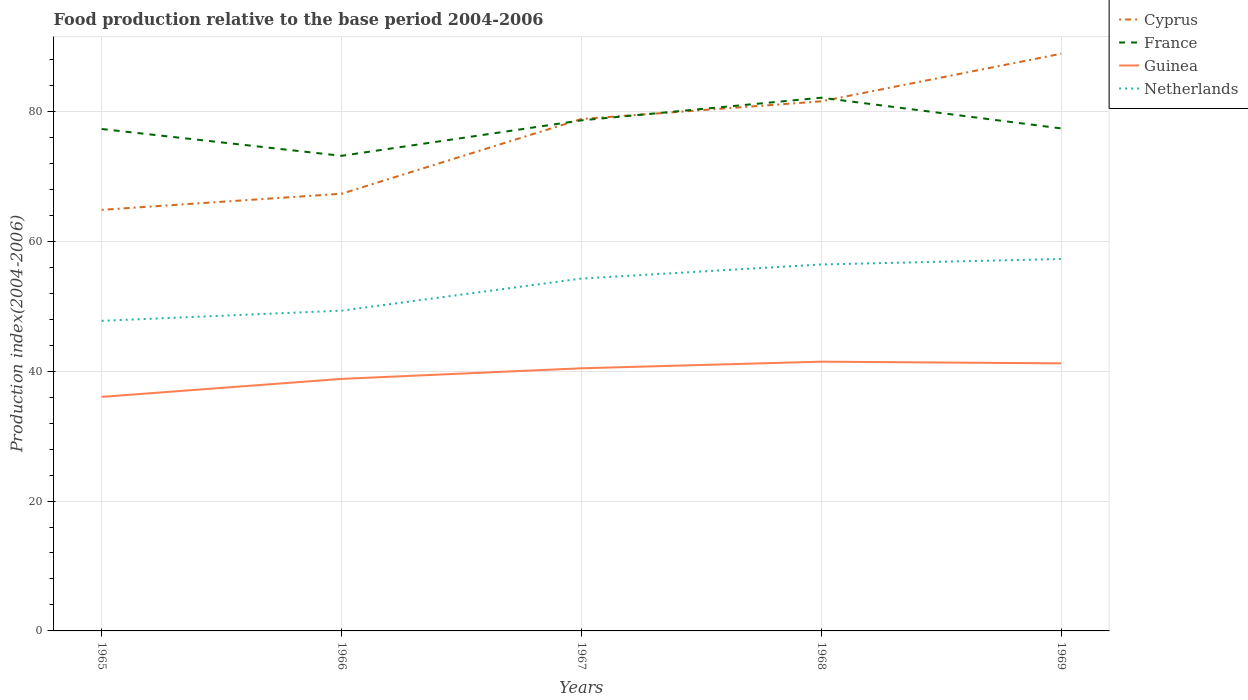How many different coloured lines are there?
Your response must be concise. 4. Across all years, what is the maximum food production index in France?
Your answer should be compact. 73.16. In which year was the food production index in Netherlands maximum?
Provide a succinct answer. 1965. What is the total food production index in France in the graph?
Offer a terse response. -3.49. What is the difference between the highest and the second highest food production index in Cyprus?
Offer a terse response. 24.04. Is the food production index in Cyprus strictly greater than the food production index in France over the years?
Your response must be concise. No. How many lines are there?
Provide a succinct answer. 4. Are the values on the major ticks of Y-axis written in scientific E-notation?
Your response must be concise. No. Does the graph contain any zero values?
Offer a very short reply. No. Does the graph contain grids?
Provide a short and direct response. Yes. What is the title of the graph?
Your answer should be compact. Food production relative to the base period 2004-2006. What is the label or title of the Y-axis?
Keep it short and to the point. Production index(2004-2006). What is the Production index(2004-2006) of Cyprus in 1965?
Ensure brevity in your answer.  64.84. What is the Production index(2004-2006) in France in 1965?
Keep it short and to the point. 77.29. What is the Production index(2004-2006) in Guinea in 1965?
Keep it short and to the point. 36.04. What is the Production index(2004-2006) of Netherlands in 1965?
Give a very brief answer. 47.75. What is the Production index(2004-2006) of Cyprus in 1966?
Give a very brief answer. 67.32. What is the Production index(2004-2006) in France in 1966?
Provide a succinct answer. 73.16. What is the Production index(2004-2006) of Guinea in 1966?
Make the answer very short. 38.81. What is the Production index(2004-2006) of Netherlands in 1966?
Make the answer very short. 49.32. What is the Production index(2004-2006) in Cyprus in 1967?
Offer a very short reply. 78.83. What is the Production index(2004-2006) in France in 1967?
Your answer should be compact. 78.62. What is the Production index(2004-2006) of Guinea in 1967?
Make the answer very short. 40.44. What is the Production index(2004-2006) of Netherlands in 1967?
Make the answer very short. 54.26. What is the Production index(2004-2006) of Cyprus in 1968?
Offer a very short reply. 81.55. What is the Production index(2004-2006) in France in 1968?
Provide a succinct answer. 82.11. What is the Production index(2004-2006) of Guinea in 1968?
Give a very brief answer. 41.46. What is the Production index(2004-2006) of Netherlands in 1968?
Give a very brief answer. 56.43. What is the Production index(2004-2006) in Cyprus in 1969?
Your answer should be compact. 88.88. What is the Production index(2004-2006) in France in 1969?
Your answer should be compact. 77.38. What is the Production index(2004-2006) of Guinea in 1969?
Provide a succinct answer. 41.2. What is the Production index(2004-2006) in Netherlands in 1969?
Make the answer very short. 57.27. Across all years, what is the maximum Production index(2004-2006) in Cyprus?
Your response must be concise. 88.88. Across all years, what is the maximum Production index(2004-2006) in France?
Offer a terse response. 82.11. Across all years, what is the maximum Production index(2004-2006) in Guinea?
Provide a short and direct response. 41.46. Across all years, what is the maximum Production index(2004-2006) in Netherlands?
Make the answer very short. 57.27. Across all years, what is the minimum Production index(2004-2006) in Cyprus?
Ensure brevity in your answer.  64.84. Across all years, what is the minimum Production index(2004-2006) in France?
Make the answer very short. 73.16. Across all years, what is the minimum Production index(2004-2006) in Guinea?
Provide a short and direct response. 36.04. Across all years, what is the minimum Production index(2004-2006) in Netherlands?
Your answer should be very brief. 47.75. What is the total Production index(2004-2006) of Cyprus in the graph?
Offer a terse response. 381.42. What is the total Production index(2004-2006) of France in the graph?
Offer a very short reply. 388.56. What is the total Production index(2004-2006) in Guinea in the graph?
Your response must be concise. 197.95. What is the total Production index(2004-2006) in Netherlands in the graph?
Make the answer very short. 265.03. What is the difference between the Production index(2004-2006) of Cyprus in 1965 and that in 1966?
Your answer should be compact. -2.48. What is the difference between the Production index(2004-2006) of France in 1965 and that in 1966?
Offer a terse response. 4.13. What is the difference between the Production index(2004-2006) of Guinea in 1965 and that in 1966?
Make the answer very short. -2.77. What is the difference between the Production index(2004-2006) of Netherlands in 1965 and that in 1966?
Your answer should be compact. -1.57. What is the difference between the Production index(2004-2006) in Cyprus in 1965 and that in 1967?
Offer a very short reply. -13.99. What is the difference between the Production index(2004-2006) of France in 1965 and that in 1967?
Provide a short and direct response. -1.33. What is the difference between the Production index(2004-2006) in Guinea in 1965 and that in 1967?
Ensure brevity in your answer.  -4.4. What is the difference between the Production index(2004-2006) in Netherlands in 1965 and that in 1967?
Provide a short and direct response. -6.51. What is the difference between the Production index(2004-2006) of Cyprus in 1965 and that in 1968?
Your answer should be very brief. -16.71. What is the difference between the Production index(2004-2006) of France in 1965 and that in 1968?
Make the answer very short. -4.82. What is the difference between the Production index(2004-2006) of Guinea in 1965 and that in 1968?
Make the answer very short. -5.42. What is the difference between the Production index(2004-2006) in Netherlands in 1965 and that in 1968?
Your answer should be very brief. -8.68. What is the difference between the Production index(2004-2006) of Cyprus in 1965 and that in 1969?
Offer a terse response. -24.04. What is the difference between the Production index(2004-2006) of France in 1965 and that in 1969?
Provide a succinct answer. -0.09. What is the difference between the Production index(2004-2006) in Guinea in 1965 and that in 1969?
Offer a terse response. -5.16. What is the difference between the Production index(2004-2006) of Netherlands in 1965 and that in 1969?
Offer a very short reply. -9.52. What is the difference between the Production index(2004-2006) of Cyprus in 1966 and that in 1967?
Make the answer very short. -11.51. What is the difference between the Production index(2004-2006) of France in 1966 and that in 1967?
Keep it short and to the point. -5.46. What is the difference between the Production index(2004-2006) of Guinea in 1966 and that in 1967?
Your answer should be very brief. -1.63. What is the difference between the Production index(2004-2006) of Netherlands in 1966 and that in 1967?
Make the answer very short. -4.94. What is the difference between the Production index(2004-2006) of Cyprus in 1966 and that in 1968?
Make the answer very short. -14.23. What is the difference between the Production index(2004-2006) in France in 1966 and that in 1968?
Offer a very short reply. -8.95. What is the difference between the Production index(2004-2006) of Guinea in 1966 and that in 1968?
Keep it short and to the point. -2.65. What is the difference between the Production index(2004-2006) of Netherlands in 1966 and that in 1968?
Your answer should be very brief. -7.11. What is the difference between the Production index(2004-2006) of Cyprus in 1966 and that in 1969?
Ensure brevity in your answer.  -21.56. What is the difference between the Production index(2004-2006) of France in 1966 and that in 1969?
Ensure brevity in your answer.  -4.22. What is the difference between the Production index(2004-2006) of Guinea in 1966 and that in 1969?
Give a very brief answer. -2.39. What is the difference between the Production index(2004-2006) of Netherlands in 1966 and that in 1969?
Provide a short and direct response. -7.95. What is the difference between the Production index(2004-2006) in Cyprus in 1967 and that in 1968?
Your response must be concise. -2.72. What is the difference between the Production index(2004-2006) in France in 1967 and that in 1968?
Offer a terse response. -3.49. What is the difference between the Production index(2004-2006) of Guinea in 1967 and that in 1968?
Offer a very short reply. -1.02. What is the difference between the Production index(2004-2006) in Netherlands in 1967 and that in 1968?
Offer a terse response. -2.17. What is the difference between the Production index(2004-2006) of Cyprus in 1967 and that in 1969?
Your response must be concise. -10.05. What is the difference between the Production index(2004-2006) of France in 1967 and that in 1969?
Your answer should be compact. 1.24. What is the difference between the Production index(2004-2006) in Guinea in 1967 and that in 1969?
Make the answer very short. -0.76. What is the difference between the Production index(2004-2006) of Netherlands in 1967 and that in 1969?
Offer a terse response. -3.01. What is the difference between the Production index(2004-2006) in Cyprus in 1968 and that in 1969?
Keep it short and to the point. -7.33. What is the difference between the Production index(2004-2006) of France in 1968 and that in 1969?
Give a very brief answer. 4.73. What is the difference between the Production index(2004-2006) of Guinea in 1968 and that in 1969?
Your response must be concise. 0.26. What is the difference between the Production index(2004-2006) in Netherlands in 1968 and that in 1969?
Provide a short and direct response. -0.84. What is the difference between the Production index(2004-2006) of Cyprus in 1965 and the Production index(2004-2006) of France in 1966?
Give a very brief answer. -8.32. What is the difference between the Production index(2004-2006) in Cyprus in 1965 and the Production index(2004-2006) in Guinea in 1966?
Your response must be concise. 26.03. What is the difference between the Production index(2004-2006) in Cyprus in 1965 and the Production index(2004-2006) in Netherlands in 1966?
Offer a very short reply. 15.52. What is the difference between the Production index(2004-2006) in France in 1965 and the Production index(2004-2006) in Guinea in 1966?
Offer a very short reply. 38.48. What is the difference between the Production index(2004-2006) of France in 1965 and the Production index(2004-2006) of Netherlands in 1966?
Your answer should be very brief. 27.97. What is the difference between the Production index(2004-2006) in Guinea in 1965 and the Production index(2004-2006) in Netherlands in 1966?
Ensure brevity in your answer.  -13.28. What is the difference between the Production index(2004-2006) of Cyprus in 1965 and the Production index(2004-2006) of France in 1967?
Offer a terse response. -13.78. What is the difference between the Production index(2004-2006) of Cyprus in 1965 and the Production index(2004-2006) of Guinea in 1967?
Provide a short and direct response. 24.4. What is the difference between the Production index(2004-2006) of Cyprus in 1965 and the Production index(2004-2006) of Netherlands in 1967?
Offer a very short reply. 10.58. What is the difference between the Production index(2004-2006) in France in 1965 and the Production index(2004-2006) in Guinea in 1967?
Give a very brief answer. 36.85. What is the difference between the Production index(2004-2006) of France in 1965 and the Production index(2004-2006) of Netherlands in 1967?
Give a very brief answer. 23.03. What is the difference between the Production index(2004-2006) of Guinea in 1965 and the Production index(2004-2006) of Netherlands in 1967?
Provide a succinct answer. -18.22. What is the difference between the Production index(2004-2006) of Cyprus in 1965 and the Production index(2004-2006) of France in 1968?
Your response must be concise. -17.27. What is the difference between the Production index(2004-2006) in Cyprus in 1965 and the Production index(2004-2006) in Guinea in 1968?
Provide a short and direct response. 23.38. What is the difference between the Production index(2004-2006) in Cyprus in 1965 and the Production index(2004-2006) in Netherlands in 1968?
Provide a succinct answer. 8.41. What is the difference between the Production index(2004-2006) of France in 1965 and the Production index(2004-2006) of Guinea in 1968?
Offer a very short reply. 35.83. What is the difference between the Production index(2004-2006) in France in 1965 and the Production index(2004-2006) in Netherlands in 1968?
Keep it short and to the point. 20.86. What is the difference between the Production index(2004-2006) of Guinea in 1965 and the Production index(2004-2006) of Netherlands in 1968?
Your answer should be very brief. -20.39. What is the difference between the Production index(2004-2006) of Cyprus in 1965 and the Production index(2004-2006) of France in 1969?
Provide a short and direct response. -12.54. What is the difference between the Production index(2004-2006) of Cyprus in 1965 and the Production index(2004-2006) of Guinea in 1969?
Your answer should be very brief. 23.64. What is the difference between the Production index(2004-2006) of Cyprus in 1965 and the Production index(2004-2006) of Netherlands in 1969?
Offer a terse response. 7.57. What is the difference between the Production index(2004-2006) of France in 1965 and the Production index(2004-2006) of Guinea in 1969?
Give a very brief answer. 36.09. What is the difference between the Production index(2004-2006) of France in 1965 and the Production index(2004-2006) of Netherlands in 1969?
Keep it short and to the point. 20.02. What is the difference between the Production index(2004-2006) of Guinea in 1965 and the Production index(2004-2006) of Netherlands in 1969?
Give a very brief answer. -21.23. What is the difference between the Production index(2004-2006) in Cyprus in 1966 and the Production index(2004-2006) in Guinea in 1967?
Offer a very short reply. 26.88. What is the difference between the Production index(2004-2006) in Cyprus in 1966 and the Production index(2004-2006) in Netherlands in 1967?
Give a very brief answer. 13.06. What is the difference between the Production index(2004-2006) of France in 1966 and the Production index(2004-2006) of Guinea in 1967?
Provide a succinct answer. 32.72. What is the difference between the Production index(2004-2006) in France in 1966 and the Production index(2004-2006) in Netherlands in 1967?
Your answer should be compact. 18.9. What is the difference between the Production index(2004-2006) in Guinea in 1966 and the Production index(2004-2006) in Netherlands in 1967?
Ensure brevity in your answer.  -15.45. What is the difference between the Production index(2004-2006) in Cyprus in 1966 and the Production index(2004-2006) in France in 1968?
Your answer should be very brief. -14.79. What is the difference between the Production index(2004-2006) in Cyprus in 1966 and the Production index(2004-2006) in Guinea in 1968?
Provide a short and direct response. 25.86. What is the difference between the Production index(2004-2006) of Cyprus in 1966 and the Production index(2004-2006) of Netherlands in 1968?
Offer a terse response. 10.89. What is the difference between the Production index(2004-2006) in France in 1966 and the Production index(2004-2006) in Guinea in 1968?
Ensure brevity in your answer.  31.7. What is the difference between the Production index(2004-2006) of France in 1966 and the Production index(2004-2006) of Netherlands in 1968?
Your answer should be very brief. 16.73. What is the difference between the Production index(2004-2006) in Guinea in 1966 and the Production index(2004-2006) in Netherlands in 1968?
Make the answer very short. -17.62. What is the difference between the Production index(2004-2006) in Cyprus in 1966 and the Production index(2004-2006) in France in 1969?
Provide a short and direct response. -10.06. What is the difference between the Production index(2004-2006) of Cyprus in 1966 and the Production index(2004-2006) of Guinea in 1969?
Provide a short and direct response. 26.12. What is the difference between the Production index(2004-2006) of Cyprus in 1966 and the Production index(2004-2006) of Netherlands in 1969?
Make the answer very short. 10.05. What is the difference between the Production index(2004-2006) in France in 1966 and the Production index(2004-2006) in Guinea in 1969?
Your answer should be very brief. 31.96. What is the difference between the Production index(2004-2006) in France in 1966 and the Production index(2004-2006) in Netherlands in 1969?
Provide a succinct answer. 15.89. What is the difference between the Production index(2004-2006) of Guinea in 1966 and the Production index(2004-2006) of Netherlands in 1969?
Keep it short and to the point. -18.46. What is the difference between the Production index(2004-2006) in Cyprus in 1967 and the Production index(2004-2006) in France in 1968?
Provide a short and direct response. -3.28. What is the difference between the Production index(2004-2006) of Cyprus in 1967 and the Production index(2004-2006) of Guinea in 1968?
Your response must be concise. 37.37. What is the difference between the Production index(2004-2006) of Cyprus in 1967 and the Production index(2004-2006) of Netherlands in 1968?
Ensure brevity in your answer.  22.4. What is the difference between the Production index(2004-2006) in France in 1967 and the Production index(2004-2006) in Guinea in 1968?
Your answer should be very brief. 37.16. What is the difference between the Production index(2004-2006) of France in 1967 and the Production index(2004-2006) of Netherlands in 1968?
Make the answer very short. 22.19. What is the difference between the Production index(2004-2006) of Guinea in 1967 and the Production index(2004-2006) of Netherlands in 1968?
Make the answer very short. -15.99. What is the difference between the Production index(2004-2006) in Cyprus in 1967 and the Production index(2004-2006) in France in 1969?
Provide a short and direct response. 1.45. What is the difference between the Production index(2004-2006) of Cyprus in 1967 and the Production index(2004-2006) of Guinea in 1969?
Make the answer very short. 37.63. What is the difference between the Production index(2004-2006) in Cyprus in 1967 and the Production index(2004-2006) in Netherlands in 1969?
Provide a succinct answer. 21.56. What is the difference between the Production index(2004-2006) of France in 1967 and the Production index(2004-2006) of Guinea in 1969?
Offer a very short reply. 37.42. What is the difference between the Production index(2004-2006) of France in 1967 and the Production index(2004-2006) of Netherlands in 1969?
Your answer should be very brief. 21.35. What is the difference between the Production index(2004-2006) of Guinea in 1967 and the Production index(2004-2006) of Netherlands in 1969?
Provide a succinct answer. -16.83. What is the difference between the Production index(2004-2006) in Cyprus in 1968 and the Production index(2004-2006) in France in 1969?
Give a very brief answer. 4.17. What is the difference between the Production index(2004-2006) of Cyprus in 1968 and the Production index(2004-2006) of Guinea in 1969?
Provide a short and direct response. 40.35. What is the difference between the Production index(2004-2006) of Cyprus in 1968 and the Production index(2004-2006) of Netherlands in 1969?
Give a very brief answer. 24.28. What is the difference between the Production index(2004-2006) of France in 1968 and the Production index(2004-2006) of Guinea in 1969?
Ensure brevity in your answer.  40.91. What is the difference between the Production index(2004-2006) in France in 1968 and the Production index(2004-2006) in Netherlands in 1969?
Provide a succinct answer. 24.84. What is the difference between the Production index(2004-2006) of Guinea in 1968 and the Production index(2004-2006) of Netherlands in 1969?
Offer a very short reply. -15.81. What is the average Production index(2004-2006) in Cyprus per year?
Ensure brevity in your answer.  76.28. What is the average Production index(2004-2006) in France per year?
Your response must be concise. 77.71. What is the average Production index(2004-2006) in Guinea per year?
Offer a terse response. 39.59. What is the average Production index(2004-2006) in Netherlands per year?
Give a very brief answer. 53.01. In the year 1965, what is the difference between the Production index(2004-2006) in Cyprus and Production index(2004-2006) in France?
Your answer should be compact. -12.45. In the year 1965, what is the difference between the Production index(2004-2006) of Cyprus and Production index(2004-2006) of Guinea?
Offer a very short reply. 28.8. In the year 1965, what is the difference between the Production index(2004-2006) in Cyprus and Production index(2004-2006) in Netherlands?
Provide a succinct answer. 17.09. In the year 1965, what is the difference between the Production index(2004-2006) of France and Production index(2004-2006) of Guinea?
Your answer should be very brief. 41.25. In the year 1965, what is the difference between the Production index(2004-2006) of France and Production index(2004-2006) of Netherlands?
Offer a terse response. 29.54. In the year 1965, what is the difference between the Production index(2004-2006) in Guinea and Production index(2004-2006) in Netherlands?
Make the answer very short. -11.71. In the year 1966, what is the difference between the Production index(2004-2006) in Cyprus and Production index(2004-2006) in France?
Ensure brevity in your answer.  -5.84. In the year 1966, what is the difference between the Production index(2004-2006) in Cyprus and Production index(2004-2006) in Guinea?
Keep it short and to the point. 28.51. In the year 1966, what is the difference between the Production index(2004-2006) in Cyprus and Production index(2004-2006) in Netherlands?
Keep it short and to the point. 18. In the year 1966, what is the difference between the Production index(2004-2006) of France and Production index(2004-2006) of Guinea?
Offer a terse response. 34.35. In the year 1966, what is the difference between the Production index(2004-2006) in France and Production index(2004-2006) in Netherlands?
Keep it short and to the point. 23.84. In the year 1966, what is the difference between the Production index(2004-2006) of Guinea and Production index(2004-2006) of Netherlands?
Ensure brevity in your answer.  -10.51. In the year 1967, what is the difference between the Production index(2004-2006) of Cyprus and Production index(2004-2006) of France?
Your response must be concise. 0.21. In the year 1967, what is the difference between the Production index(2004-2006) in Cyprus and Production index(2004-2006) in Guinea?
Provide a succinct answer. 38.39. In the year 1967, what is the difference between the Production index(2004-2006) in Cyprus and Production index(2004-2006) in Netherlands?
Provide a short and direct response. 24.57. In the year 1967, what is the difference between the Production index(2004-2006) in France and Production index(2004-2006) in Guinea?
Your answer should be very brief. 38.18. In the year 1967, what is the difference between the Production index(2004-2006) in France and Production index(2004-2006) in Netherlands?
Keep it short and to the point. 24.36. In the year 1967, what is the difference between the Production index(2004-2006) of Guinea and Production index(2004-2006) of Netherlands?
Ensure brevity in your answer.  -13.82. In the year 1968, what is the difference between the Production index(2004-2006) of Cyprus and Production index(2004-2006) of France?
Your answer should be very brief. -0.56. In the year 1968, what is the difference between the Production index(2004-2006) of Cyprus and Production index(2004-2006) of Guinea?
Give a very brief answer. 40.09. In the year 1968, what is the difference between the Production index(2004-2006) of Cyprus and Production index(2004-2006) of Netherlands?
Keep it short and to the point. 25.12. In the year 1968, what is the difference between the Production index(2004-2006) of France and Production index(2004-2006) of Guinea?
Offer a terse response. 40.65. In the year 1968, what is the difference between the Production index(2004-2006) of France and Production index(2004-2006) of Netherlands?
Offer a very short reply. 25.68. In the year 1968, what is the difference between the Production index(2004-2006) of Guinea and Production index(2004-2006) of Netherlands?
Offer a very short reply. -14.97. In the year 1969, what is the difference between the Production index(2004-2006) in Cyprus and Production index(2004-2006) in France?
Ensure brevity in your answer.  11.5. In the year 1969, what is the difference between the Production index(2004-2006) in Cyprus and Production index(2004-2006) in Guinea?
Make the answer very short. 47.68. In the year 1969, what is the difference between the Production index(2004-2006) in Cyprus and Production index(2004-2006) in Netherlands?
Ensure brevity in your answer.  31.61. In the year 1969, what is the difference between the Production index(2004-2006) of France and Production index(2004-2006) of Guinea?
Make the answer very short. 36.18. In the year 1969, what is the difference between the Production index(2004-2006) in France and Production index(2004-2006) in Netherlands?
Your answer should be compact. 20.11. In the year 1969, what is the difference between the Production index(2004-2006) in Guinea and Production index(2004-2006) in Netherlands?
Keep it short and to the point. -16.07. What is the ratio of the Production index(2004-2006) in Cyprus in 1965 to that in 1966?
Offer a terse response. 0.96. What is the ratio of the Production index(2004-2006) in France in 1965 to that in 1966?
Your answer should be compact. 1.06. What is the ratio of the Production index(2004-2006) in Netherlands in 1965 to that in 1966?
Ensure brevity in your answer.  0.97. What is the ratio of the Production index(2004-2006) in Cyprus in 1965 to that in 1967?
Give a very brief answer. 0.82. What is the ratio of the Production index(2004-2006) in France in 1965 to that in 1967?
Your answer should be compact. 0.98. What is the ratio of the Production index(2004-2006) of Guinea in 1965 to that in 1967?
Make the answer very short. 0.89. What is the ratio of the Production index(2004-2006) of Cyprus in 1965 to that in 1968?
Offer a very short reply. 0.8. What is the ratio of the Production index(2004-2006) of France in 1965 to that in 1968?
Provide a short and direct response. 0.94. What is the ratio of the Production index(2004-2006) of Guinea in 1965 to that in 1968?
Your answer should be compact. 0.87. What is the ratio of the Production index(2004-2006) of Netherlands in 1965 to that in 1968?
Offer a very short reply. 0.85. What is the ratio of the Production index(2004-2006) in Cyprus in 1965 to that in 1969?
Ensure brevity in your answer.  0.73. What is the ratio of the Production index(2004-2006) of Guinea in 1965 to that in 1969?
Your response must be concise. 0.87. What is the ratio of the Production index(2004-2006) of Netherlands in 1965 to that in 1969?
Ensure brevity in your answer.  0.83. What is the ratio of the Production index(2004-2006) in Cyprus in 1966 to that in 1967?
Ensure brevity in your answer.  0.85. What is the ratio of the Production index(2004-2006) in France in 1966 to that in 1967?
Keep it short and to the point. 0.93. What is the ratio of the Production index(2004-2006) in Guinea in 1966 to that in 1967?
Offer a very short reply. 0.96. What is the ratio of the Production index(2004-2006) of Netherlands in 1966 to that in 1967?
Offer a very short reply. 0.91. What is the ratio of the Production index(2004-2006) of Cyprus in 1966 to that in 1968?
Offer a terse response. 0.83. What is the ratio of the Production index(2004-2006) in France in 1966 to that in 1968?
Make the answer very short. 0.89. What is the ratio of the Production index(2004-2006) in Guinea in 1966 to that in 1968?
Offer a very short reply. 0.94. What is the ratio of the Production index(2004-2006) of Netherlands in 1966 to that in 1968?
Give a very brief answer. 0.87. What is the ratio of the Production index(2004-2006) of Cyprus in 1966 to that in 1969?
Offer a very short reply. 0.76. What is the ratio of the Production index(2004-2006) of France in 1966 to that in 1969?
Keep it short and to the point. 0.95. What is the ratio of the Production index(2004-2006) in Guinea in 1966 to that in 1969?
Provide a short and direct response. 0.94. What is the ratio of the Production index(2004-2006) of Netherlands in 1966 to that in 1969?
Give a very brief answer. 0.86. What is the ratio of the Production index(2004-2006) in Cyprus in 1967 to that in 1968?
Give a very brief answer. 0.97. What is the ratio of the Production index(2004-2006) in France in 1967 to that in 1968?
Make the answer very short. 0.96. What is the ratio of the Production index(2004-2006) in Guinea in 1967 to that in 1968?
Provide a succinct answer. 0.98. What is the ratio of the Production index(2004-2006) in Netherlands in 1967 to that in 1968?
Give a very brief answer. 0.96. What is the ratio of the Production index(2004-2006) in Cyprus in 1967 to that in 1969?
Provide a succinct answer. 0.89. What is the ratio of the Production index(2004-2006) of France in 1967 to that in 1969?
Your response must be concise. 1.02. What is the ratio of the Production index(2004-2006) of Guinea in 1967 to that in 1969?
Ensure brevity in your answer.  0.98. What is the ratio of the Production index(2004-2006) in Netherlands in 1967 to that in 1969?
Offer a terse response. 0.95. What is the ratio of the Production index(2004-2006) of Cyprus in 1968 to that in 1969?
Provide a short and direct response. 0.92. What is the ratio of the Production index(2004-2006) of France in 1968 to that in 1969?
Your answer should be compact. 1.06. What is the ratio of the Production index(2004-2006) in Netherlands in 1968 to that in 1969?
Your answer should be compact. 0.99. What is the difference between the highest and the second highest Production index(2004-2006) in Cyprus?
Your answer should be compact. 7.33. What is the difference between the highest and the second highest Production index(2004-2006) of France?
Provide a short and direct response. 3.49. What is the difference between the highest and the second highest Production index(2004-2006) of Guinea?
Make the answer very short. 0.26. What is the difference between the highest and the second highest Production index(2004-2006) of Netherlands?
Keep it short and to the point. 0.84. What is the difference between the highest and the lowest Production index(2004-2006) in Cyprus?
Ensure brevity in your answer.  24.04. What is the difference between the highest and the lowest Production index(2004-2006) in France?
Offer a terse response. 8.95. What is the difference between the highest and the lowest Production index(2004-2006) of Guinea?
Your response must be concise. 5.42. What is the difference between the highest and the lowest Production index(2004-2006) of Netherlands?
Your answer should be compact. 9.52. 